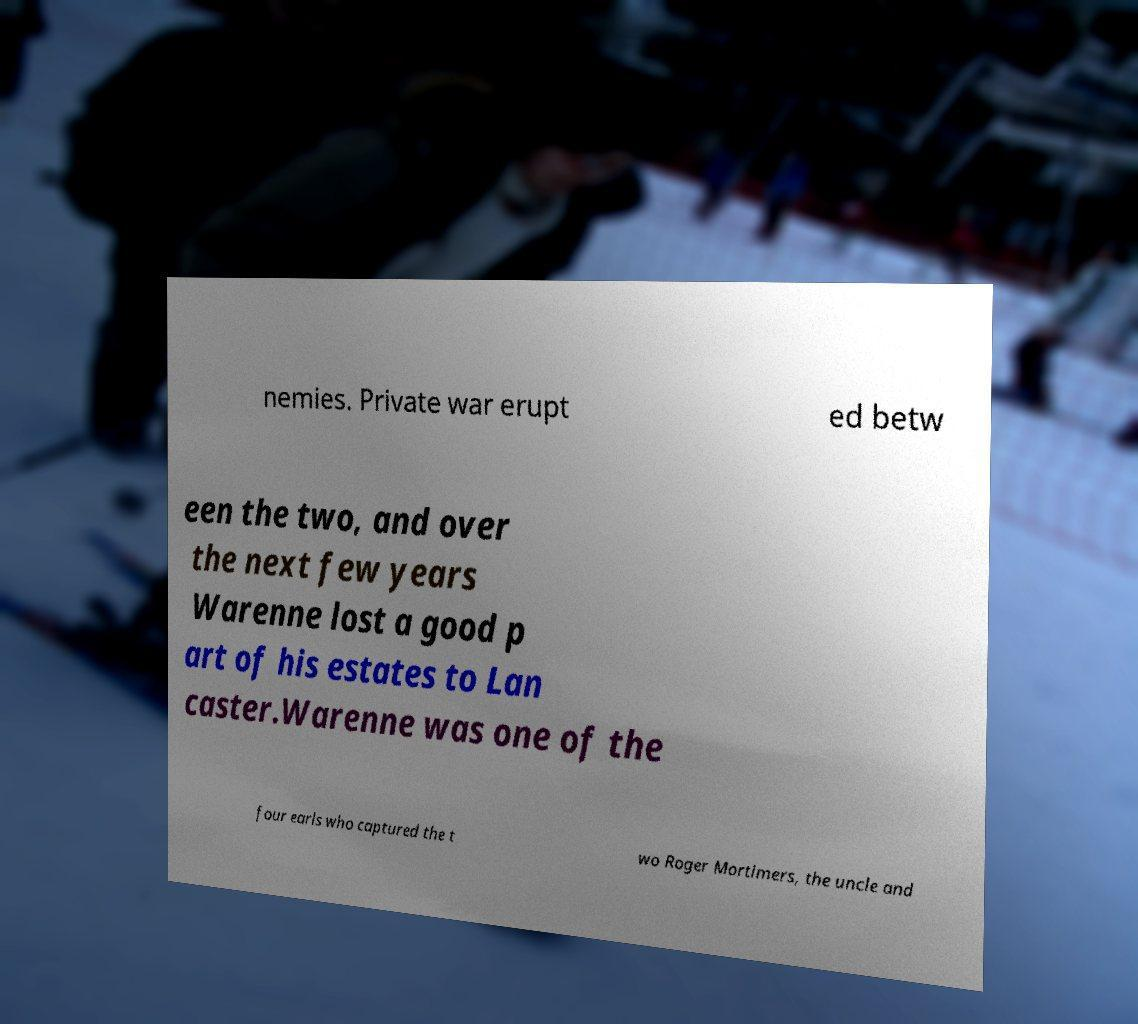Please read and relay the text visible in this image. What does it say? nemies. Private war erupt ed betw een the two, and over the next few years Warenne lost a good p art of his estates to Lan caster.Warenne was one of the four earls who captured the t wo Roger Mortimers, the uncle and 